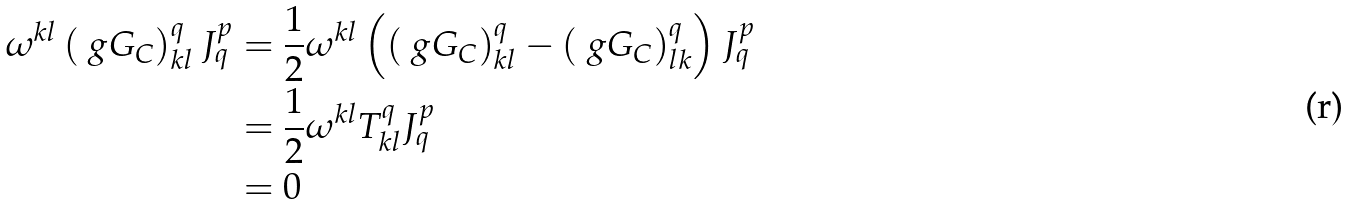<formula> <loc_0><loc_0><loc_500><loc_500>\omega ^ { k l } \left ( \ g G _ { C } \right ) _ { k l } ^ { q } J _ { q } ^ { p } = & \ \frac { 1 } { 2 } \omega ^ { k l } \left ( \left ( \ g G _ { C } \right ) _ { k l } ^ { q } - \left ( \ g G _ { C } \right ) _ { l k } ^ { q } \right ) J _ { q } ^ { p } \\ = & \ \frac { 1 } { 2 } \omega ^ { k l } T _ { k l } ^ { q } J _ { q } ^ { p } \\ = & \ 0</formula> 